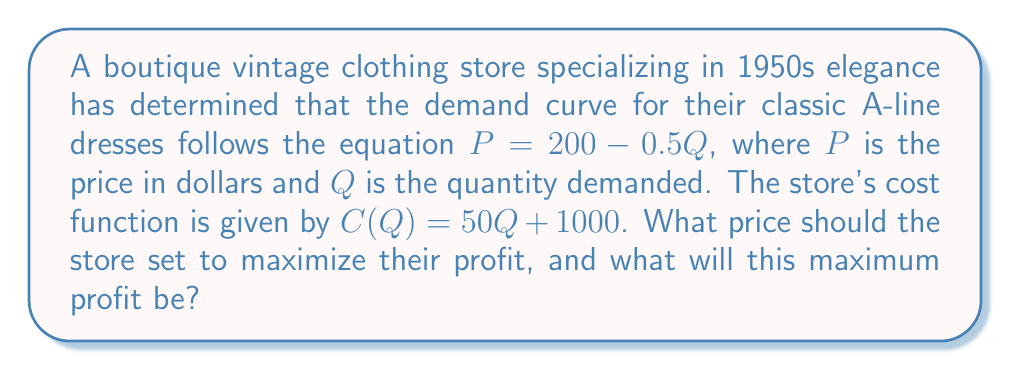Teach me how to tackle this problem. To solve this problem, we'll follow these steps:

1) First, let's find the revenue function $R(Q)$:
   $R(Q) = P \cdot Q = (200 - 0.5Q) \cdot Q = 200Q - 0.5Q^2$

2) The profit function $\Pi(Q)$ is revenue minus cost:
   $\Pi(Q) = R(Q) - C(Q) = (200Q - 0.5Q^2) - (50Q + 1000) = 150Q - 0.5Q^2 - 1000$

3) To maximize profit, we find where the derivative of $\Pi(Q)$ equals zero:
   $\frac{d\Pi}{dQ} = 150 - Q = 0$
   $Q = 150$

4) We can confirm this is a maximum by checking the second derivative:
   $\frac{d^2\Pi}{dQ^2} = -1 < 0$, confirming a maximum.

5) Now that we know the optimal quantity, we can find the optimal price:
   $P = 200 - 0.5Q = 200 - 0.5(150) = 125$

6) To find the maximum profit, we substitute $Q = 150$ into our profit function:
   $\Pi(150) = 150(150) - 0.5(150)^2 - 1000 = 22,500 - 11,250 - 1000 = 10,250$

Therefore, the store should set the price at $125 to maximize profit, which will be $10,250.
Answer: Price: $125; Maximum Profit: $10,250 